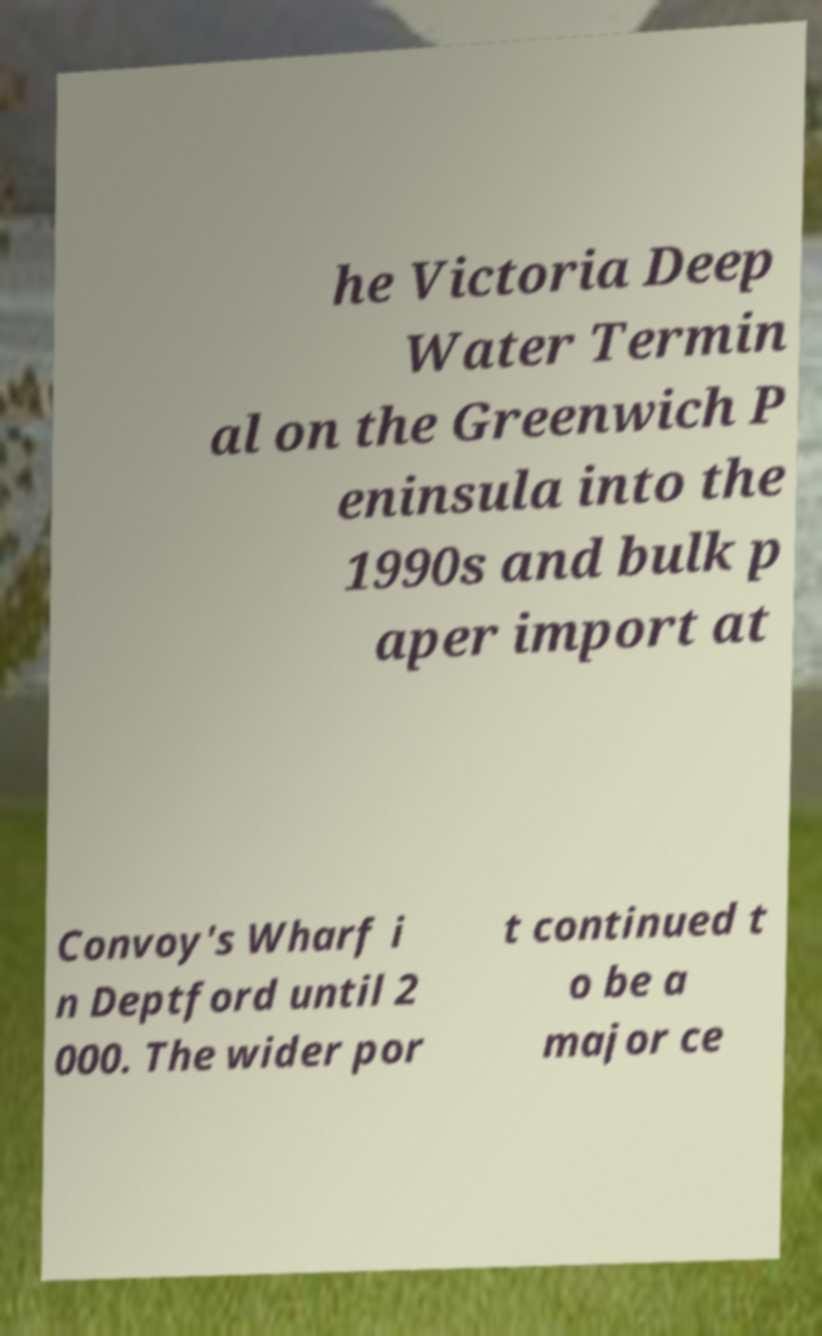What messages or text are displayed in this image? I need them in a readable, typed format. he Victoria Deep Water Termin al on the Greenwich P eninsula into the 1990s and bulk p aper import at Convoy's Wharf i n Deptford until 2 000. The wider por t continued t o be a major ce 